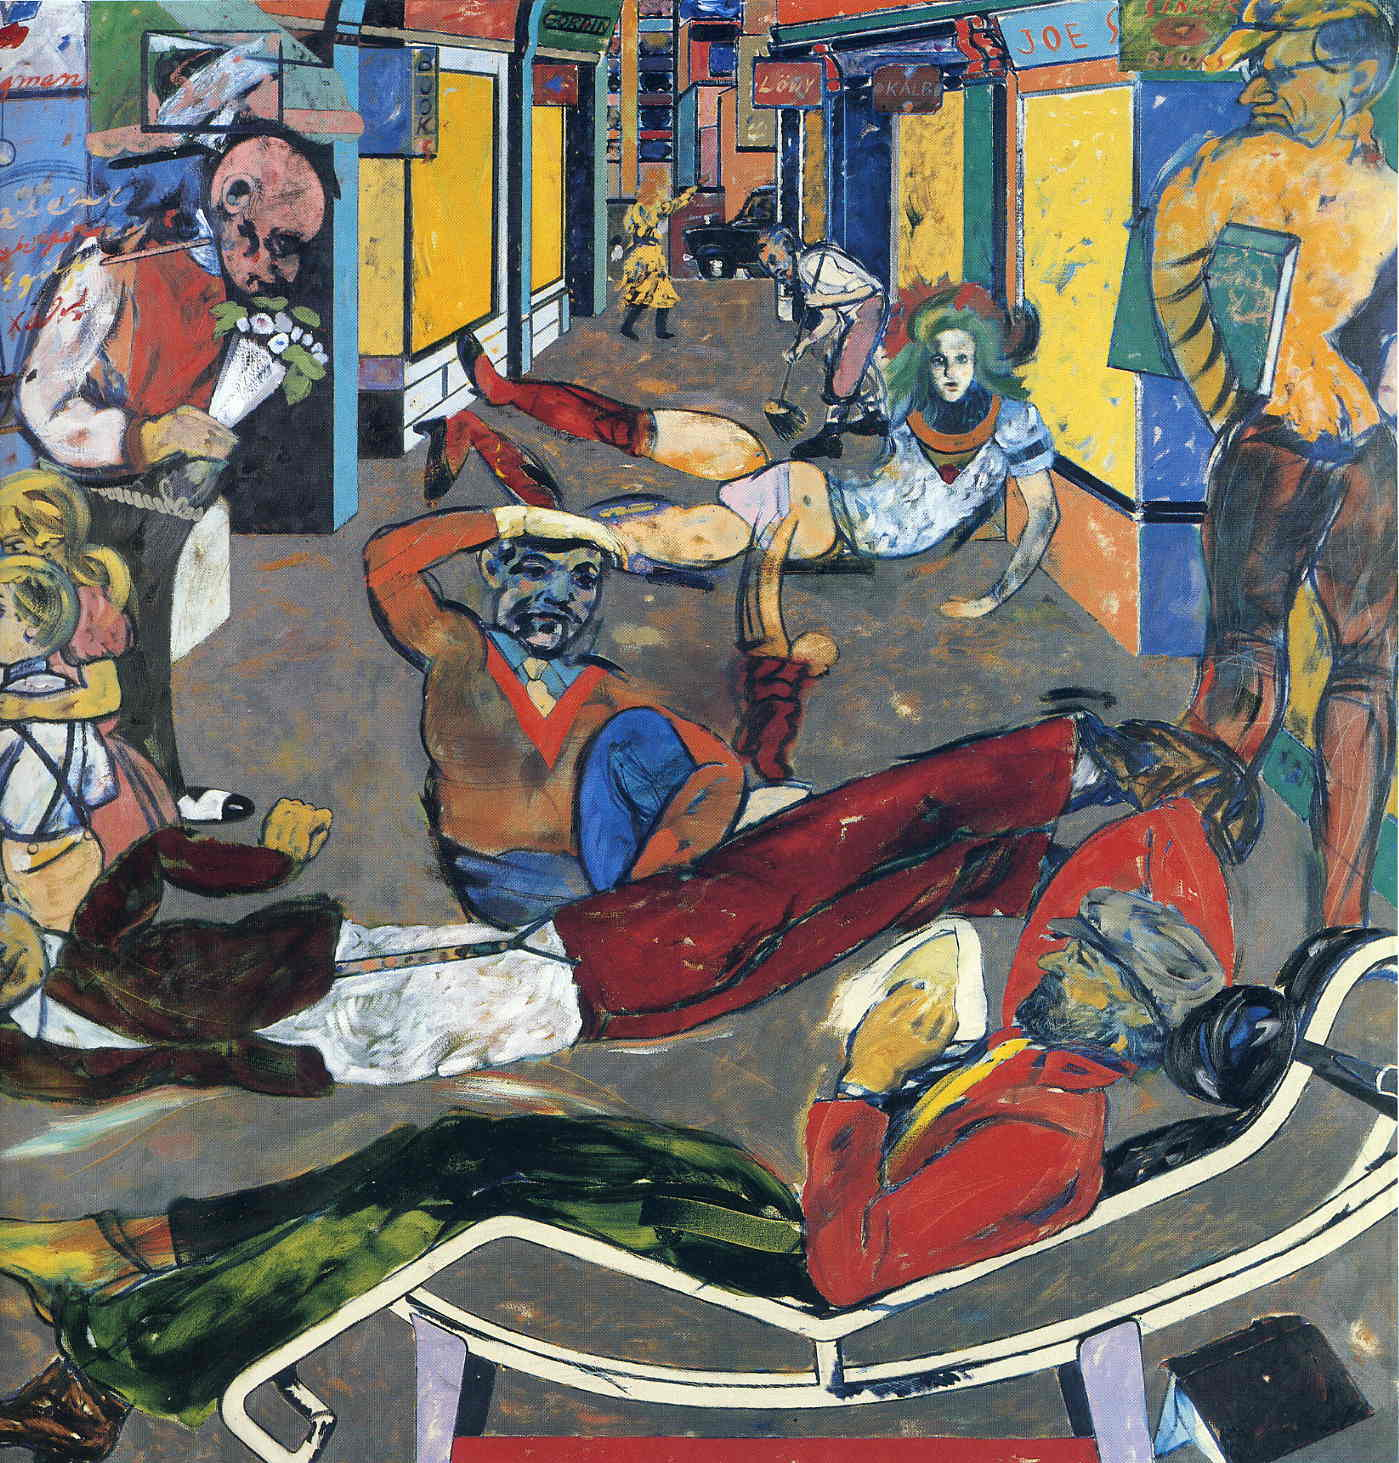Describe the artistic techniques used in this painting. The painting employs several notable artistic techniques characteristic of the expressionist style. The use of distorted and exaggerated figures draws attention to the emotional and psychological aspects of the scene rather than focusing on realism. Bold and varied colors dominate the canvas, creating a vivid and striking visual impact. The brushwork appears spontaneous and dynamic, contributing to the overall sense of movement and energy. Additionally, the composition brings together disparate elements in a seemingly chaotic yet intentional arrangement, reflecting the multifaceted nature of urban life. How would you describe the atmosphere created by the colors used? The vibrant and varied color palette fosters an atmosphere that is both chaotic and lively. The bold hues command attention and evoke a sense of urgency and excitement. Cool tones interspersed with warm colors create a striking contrast, adding depth and complexity to the scene. This interplay of colors enhances the emotional intensity of the artwork, making the viewer feel immersed in the bustling, electric energy of the depicted street. Invent a poetic description for this scene. In the heart of the city, where colors collide,
Amid the myriad shades, where stories reside,
Figures dance in a kaleidoscope hue,
Each stroke a heartbeat, vibrant and true.
The street hums with life, in a frenzied embrace,
Every corner a rhythm, every face in its place.
In this canvas of chaos, emotions take flight,
As daylight dissolves into the expressive night. If you could step into this painting, what do you think you would hear? Stepping into this painting, one would be enveloped by a cacophony of sounds—a dynamic symphony of city life. You might hear the joyous melodies of street musicians, the rhythmic tapping of dancing feet, and the lively chatter of people in animated conversation. The rustling of newspapers and the distant hum of urban activity would add to the sensory experience, creating a vivid auditory landscape that matches the visual energy of the scene. 